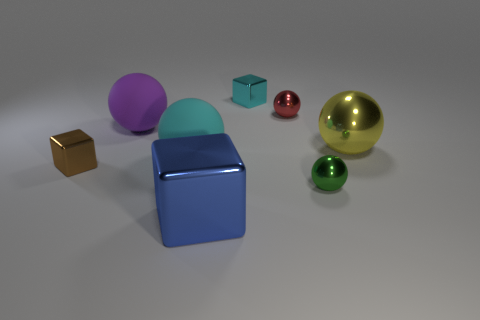Subtract all big purple matte spheres. How many spheres are left? 4 Subtract all red spheres. How many spheres are left? 4 Add 1 large matte blocks. How many objects exist? 9 Subtract all purple cubes. Subtract all brown cylinders. How many cubes are left? 3 Subtract all blocks. How many objects are left? 5 Add 6 large purple objects. How many large purple objects are left? 7 Add 8 big gray rubber things. How many big gray rubber things exist? 8 Subtract 1 cyan spheres. How many objects are left? 7 Subtract all blue things. Subtract all tiny red things. How many objects are left? 6 